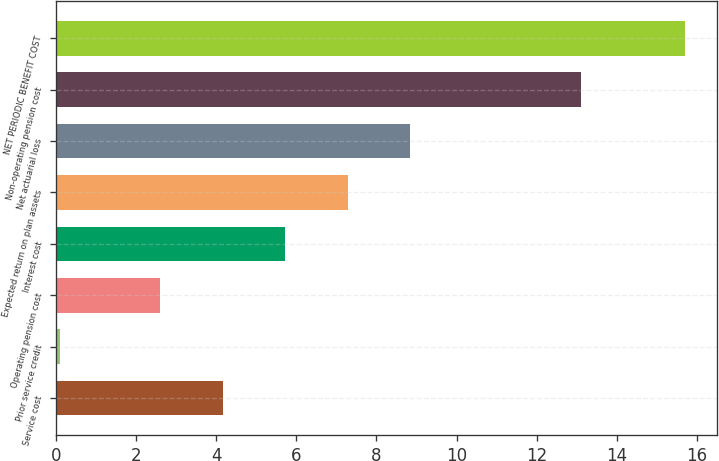Convert chart to OTSL. <chart><loc_0><loc_0><loc_500><loc_500><bar_chart><fcel>Service cost<fcel>Prior service credit<fcel>Operating pension cost<fcel>Interest cost<fcel>Expected return on plan assets<fcel>Net actuarial loss<fcel>Non-operating pension cost<fcel>NET PERIODIC BENEFIT COST<nl><fcel>4.16<fcel>0.1<fcel>2.6<fcel>5.72<fcel>7.28<fcel>8.84<fcel>13.1<fcel>15.7<nl></chart> 